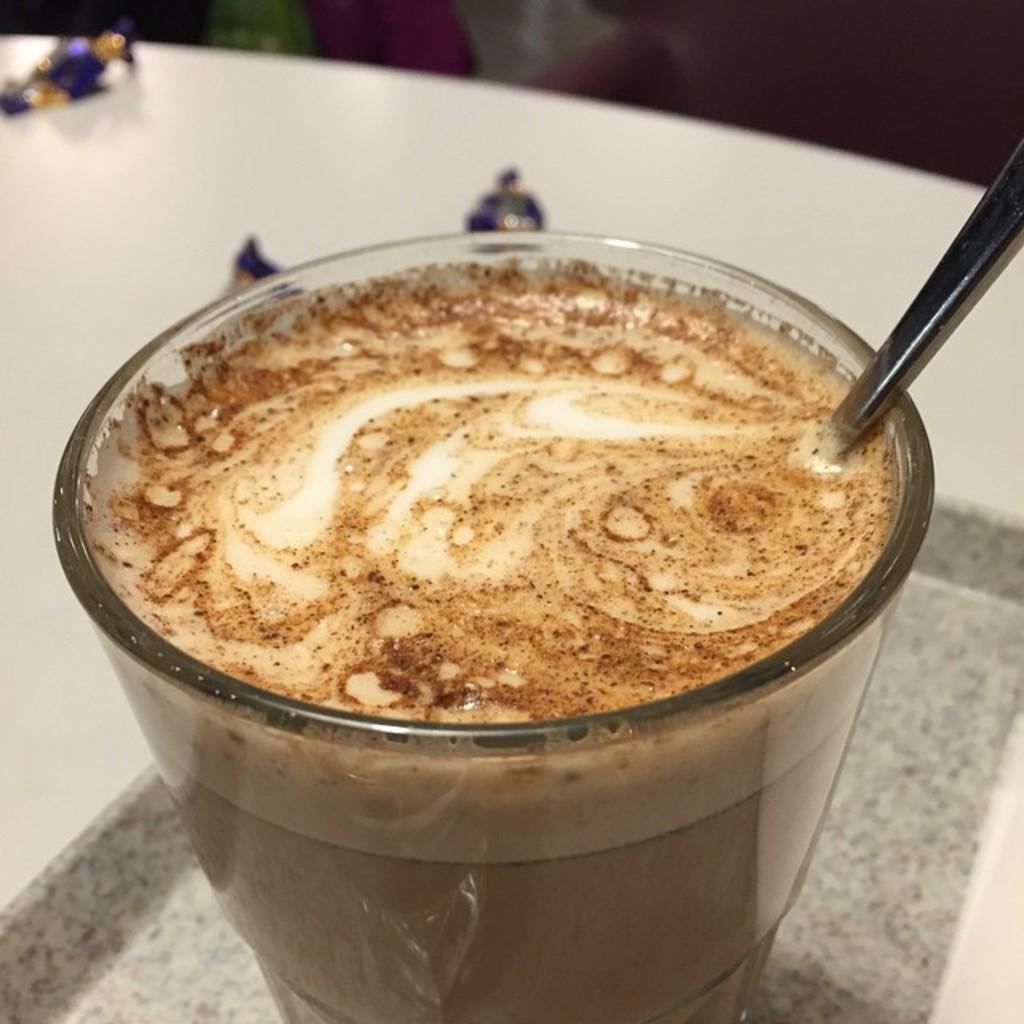What is the color of the table in the image? The table in the image is white. What is on the table in the image? There is a glass of milk mixed with coffee on the table. What is inside the glass on the table? There is a spoon in the glass on the table. How does the family join together in the image? There is no family present in the image, so it is not possible to determine how they might join together. 